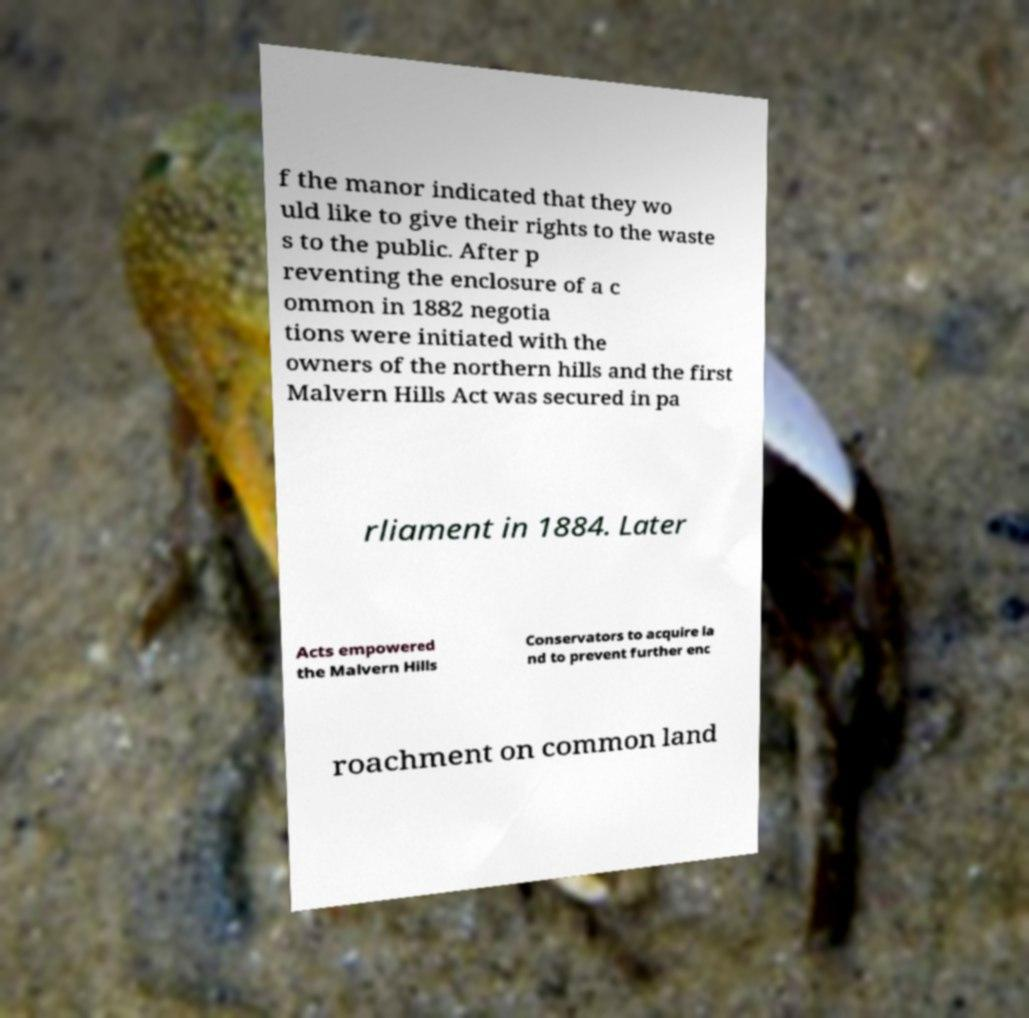I need the written content from this picture converted into text. Can you do that? f the manor indicated that they wo uld like to give their rights to the waste s to the public. After p reventing the enclosure of a c ommon in 1882 negotia tions were initiated with the owners of the northern hills and the first Malvern Hills Act was secured in pa rliament in 1884. Later Acts empowered the Malvern Hills Conservators to acquire la nd to prevent further enc roachment on common land 